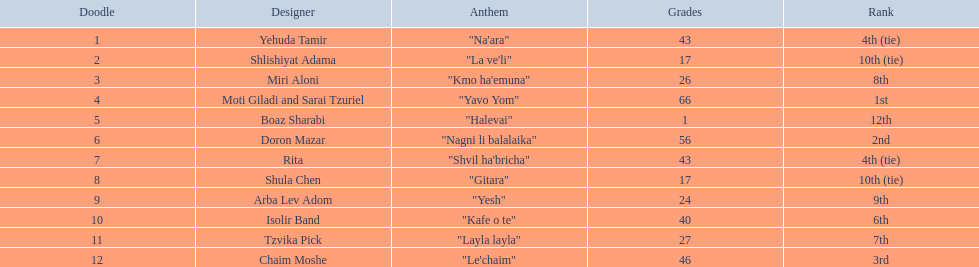Who were all the artists at the contest? Yehuda Tamir, Shlishiyat Adama, Miri Aloni, Moti Giladi and Sarai Tzuriel, Boaz Sharabi, Doron Mazar, Rita, Shula Chen, Arba Lev Adom, Isolir Band, Tzvika Pick, Chaim Moshe. What were their point totals? 43, 17, 26, 66, 1, 56, 43, 17, 24, 40, 27, 46. Of these, which is the least amount of points? 1. Which artists received this point total? Boaz Sharabi. 